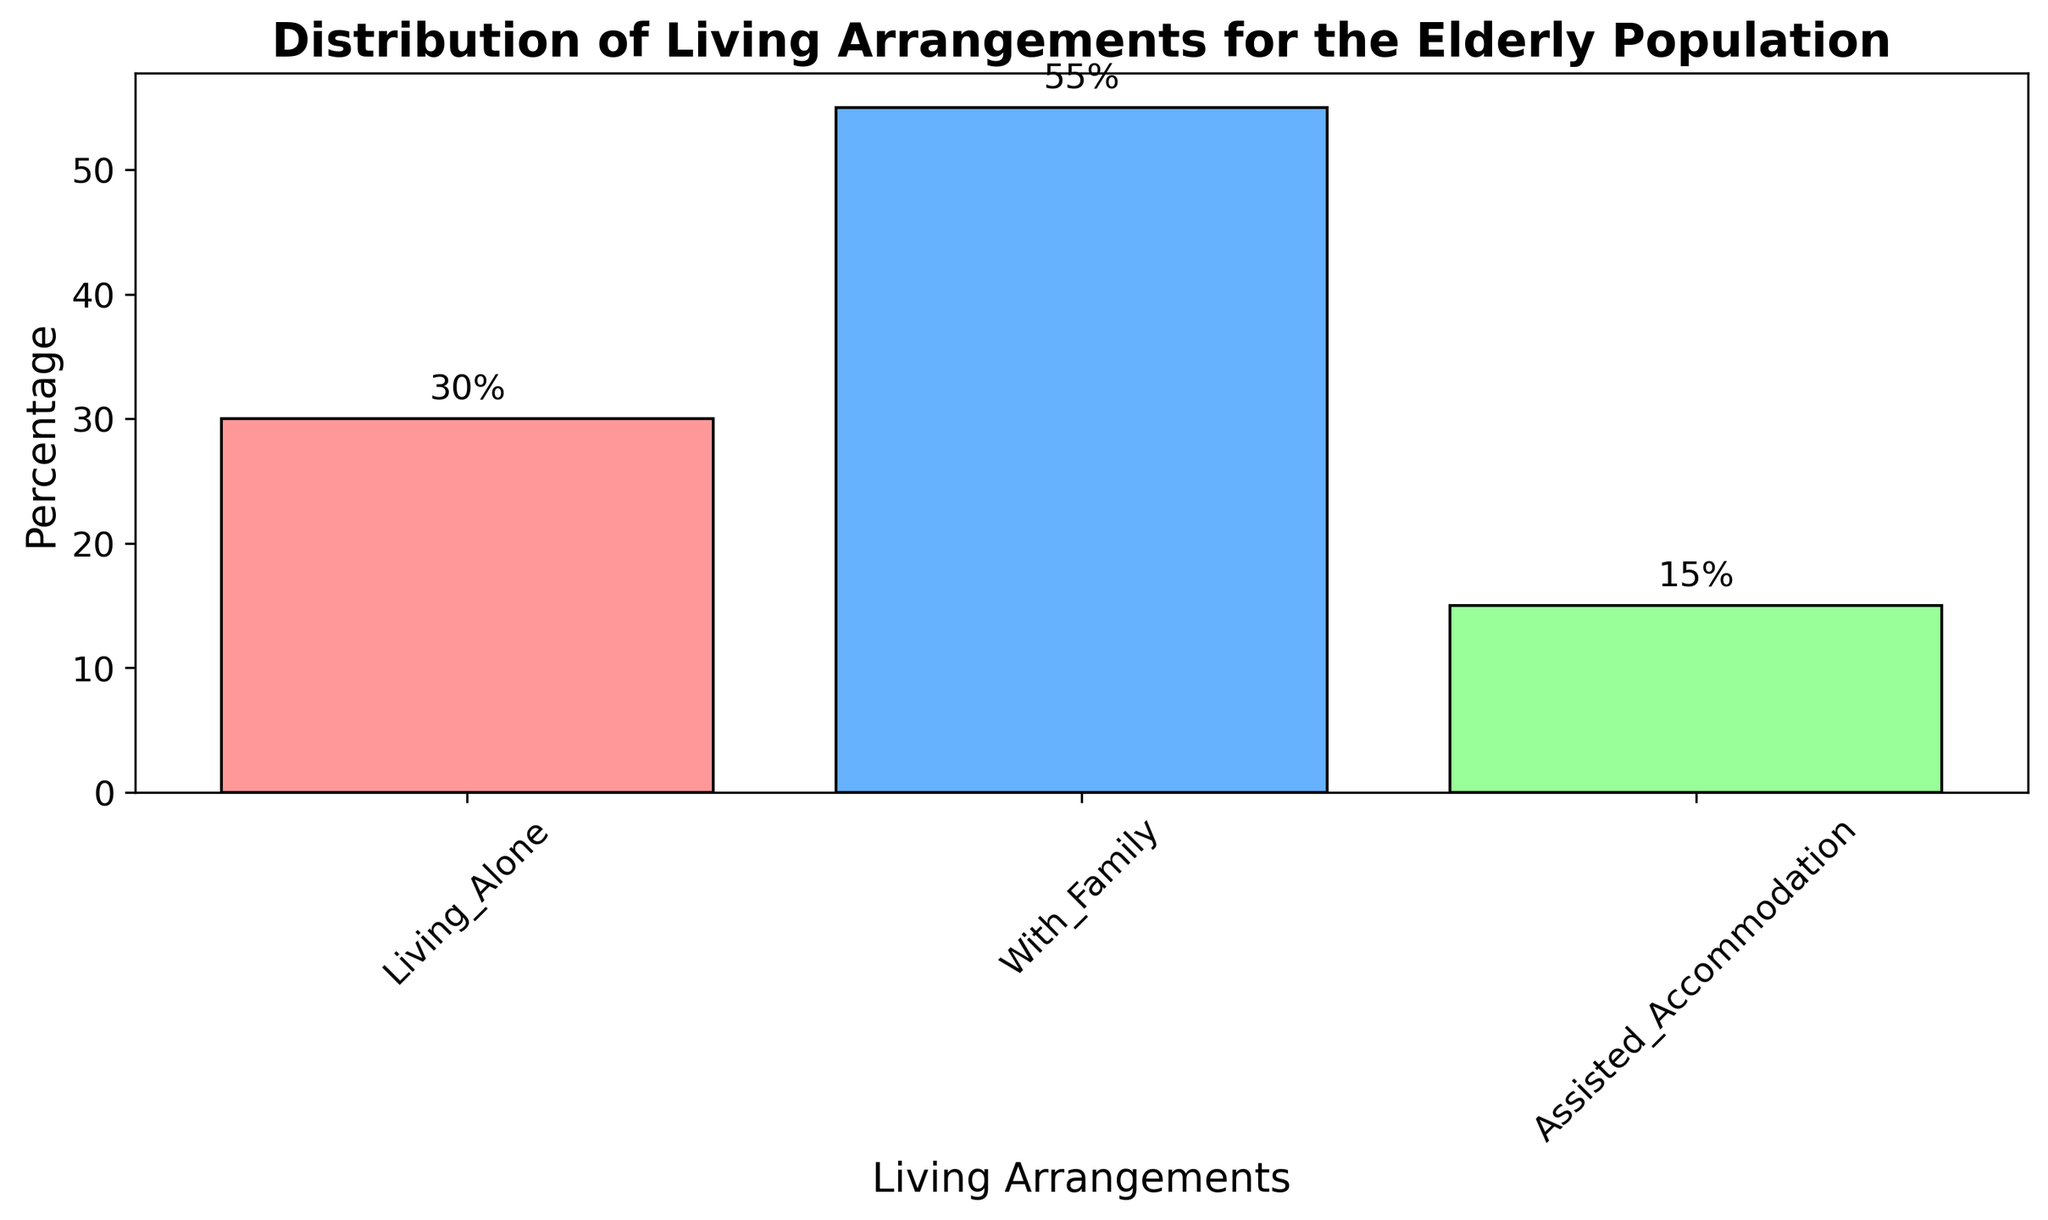Which living arrangement has the highest percentage? By observing the heights of the bars, the "With Family" category has the tallest bar, indicating it has the highest percentage.
Answer: With Family Which category has the lowest percentage of elderly population? By examining the bars, "Assisted Accommodation" has the shortest bar, indicating the lowest percentage.
Answer: Assisted Accommodation What is the combined percentage of elderly people living alone and in assisted accommodation? To find the combined percentage, add the percentages of "Living Alone" and "Assisted Accommodation"; 30% + 15% = 45%.
Answer: 45% How much larger is the percentage of elderly living with family compared to those living alone? Subtract the percentage of elderly living alone from those living with family; 55% - 30% = 25%.
Answer: 25% What is the difference in percentage between the highest and lowest categories? Subtract the smallest percentage from the largest; 55% - 15% = 40%.
Answer: 40% Which bar represents the "Assisted Accommodation" category based on its color? The "Assisted Accommodation" category is represented by the green-colored bar.
Answer: Green If the percentages are to be equally distributed among the three categories, what would be the new percentage for each? Divide the total sum of percentages by the number of categories; (30% + 55% + 15%) / 3 = 100% / 3 = 33.33%.
Answer: 33.33% What percentage difference is there between the collective population of those living with family and those either living alone or in assisted accommodation? Collective percentage for living alone or in assisted accommodation is 45%, compare it to 55%, difference is 55% - 45% = 10%.
Answer: 10% On the histogram, which bar is the tallest? The tallest bar corresponds to the "With Family" category visually.
Answer: With Family 